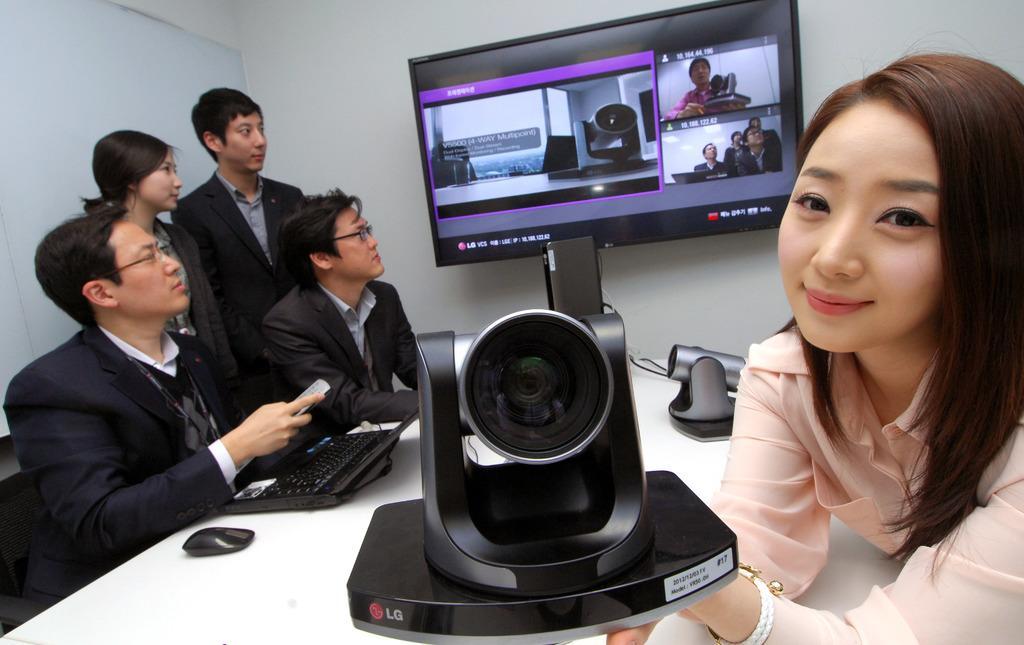Could you give a brief overview of what you see in this image? In the given image we can see there are five persons. The right side women is holding a object in her hand and the left side people are looking at the screen. 